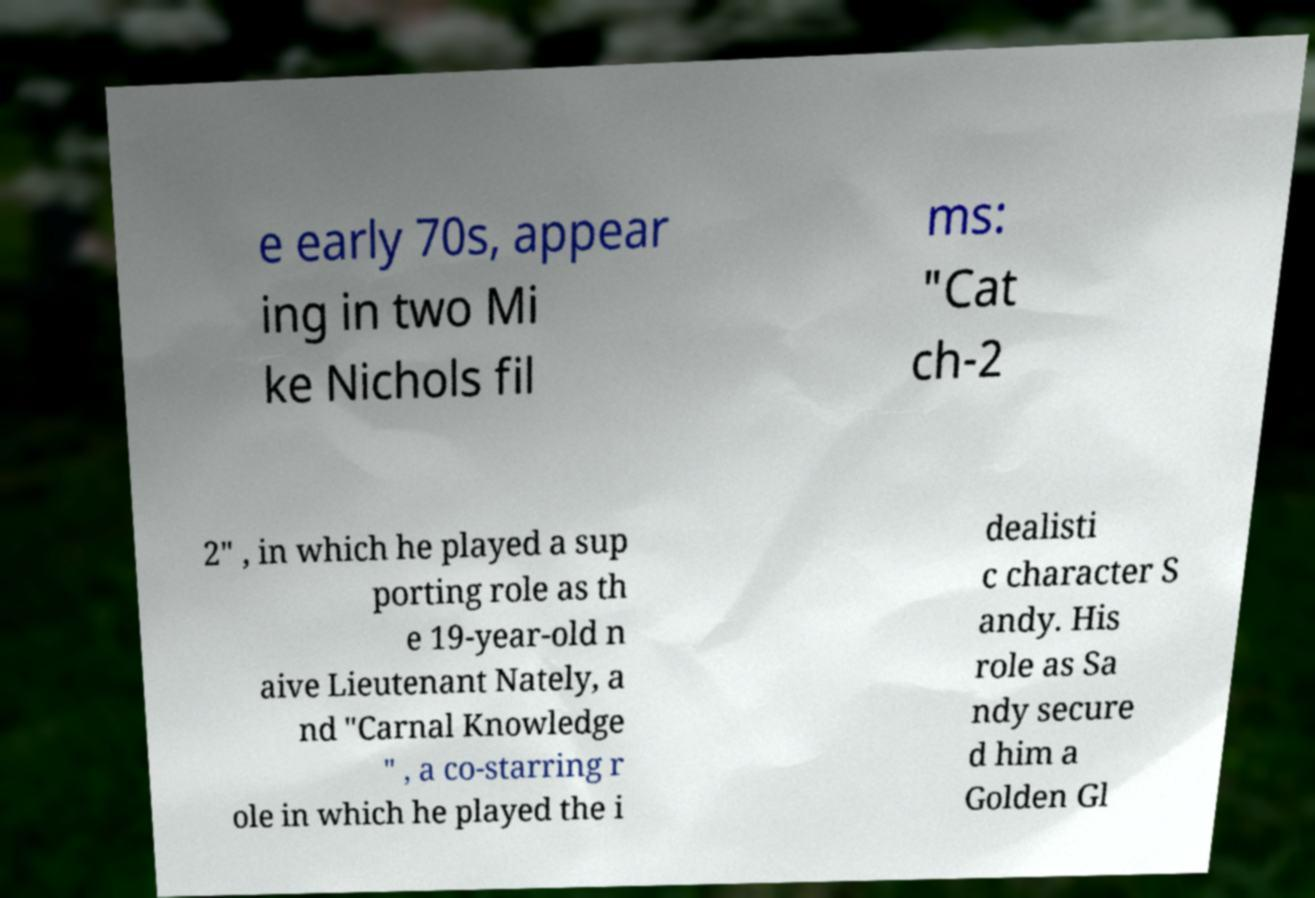Please identify and transcribe the text found in this image. e early 70s, appear ing in two Mi ke Nichols fil ms: "Cat ch-2 2" , in which he played a sup porting role as th e 19-year-old n aive Lieutenant Nately, a nd "Carnal Knowledge " , a co-starring r ole in which he played the i dealisti c character S andy. His role as Sa ndy secure d him a Golden Gl 